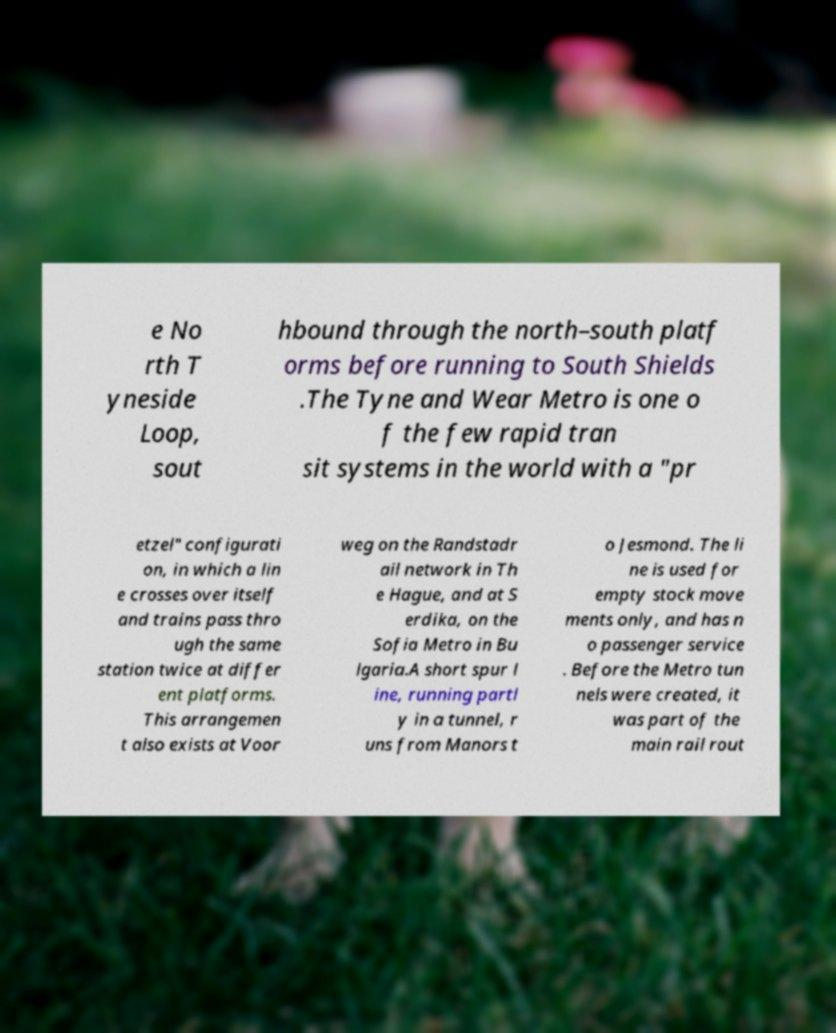Please read and relay the text visible in this image. What does it say? e No rth T yneside Loop, sout hbound through the north–south platf orms before running to South Shields .The Tyne and Wear Metro is one o f the few rapid tran sit systems in the world with a "pr etzel" configurati on, in which a lin e crosses over itself and trains pass thro ugh the same station twice at differ ent platforms. This arrangemen t also exists at Voor weg on the Randstadr ail network in Th e Hague, and at S erdika, on the Sofia Metro in Bu lgaria.A short spur l ine, running partl y in a tunnel, r uns from Manors t o Jesmond. The li ne is used for empty stock move ments only, and has n o passenger service . Before the Metro tun nels were created, it was part of the main rail rout 